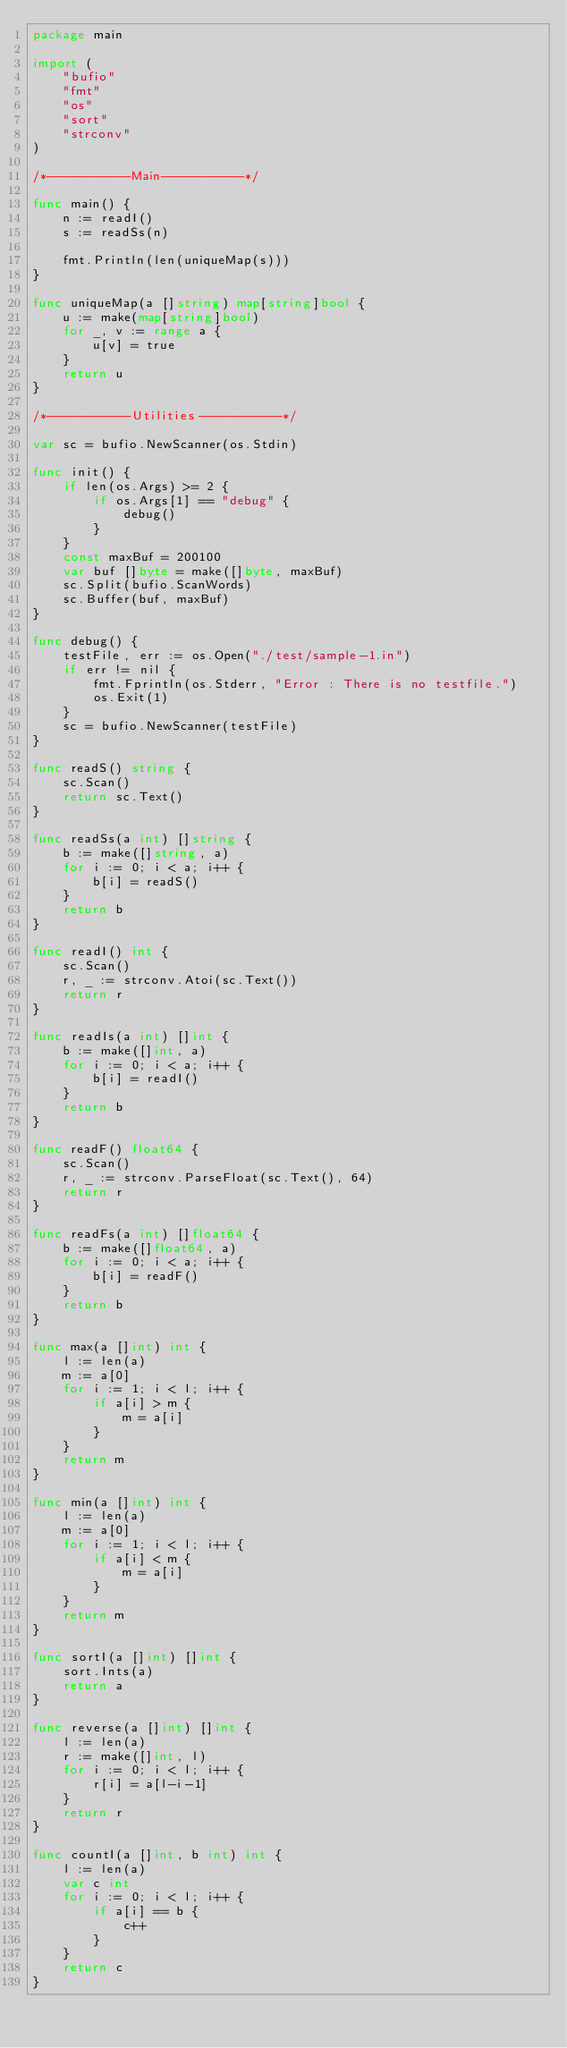Convert code to text. <code><loc_0><loc_0><loc_500><loc_500><_Go_>package main

import (
	"bufio"
	"fmt"
	"os"
	"sort"
	"strconv"
)

/*-----------Main-----------*/

func main() {
	n := readI()
	s := readSs(n)

	fmt.Println(len(uniqueMap(s)))
}

func uniqueMap(a []string) map[string]bool {
	u := make(map[string]bool)
	for _, v := range a {
		u[v] = true
	}
	return u
}

/*-----------Utilities-----------*/

var sc = bufio.NewScanner(os.Stdin)

func init() {
	if len(os.Args) >= 2 {
		if os.Args[1] == "debug" {
			debug()
		}
	}
	const maxBuf = 200100
	var buf []byte = make([]byte, maxBuf)
	sc.Split(bufio.ScanWords)
	sc.Buffer(buf, maxBuf)
}

func debug() {
	testFile, err := os.Open("./test/sample-1.in")
	if err != nil {
		fmt.Fprintln(os.Stderr, "Error : There is no testfile.")
		os.Exit(1)
	}
	sc = bufio.NewScanner(testFile)
}

func readS() string {
	sc.Scan()
	return sc.Text()
}

func readSs(a int) []string {
	b := make([]string, a)
	for i := 0; i < a; i++ {
		b[i] = readS()
	}
	return b
}

func readI() int {
	sc.Scan()
	r, _ := strconv.Atoi(sc.Text())
	return r
}

func readIs(a int) []int {
	b := make([]int, a)
	for i := 0; i < a; i++ {
		b[i] = readI()
	}
	return b
}

func readF() float64 {
	sc.Scan()
	r, _ := strconv.ParseFloat(sc.Text(), 64)
	return r
}

func readFs(a int) []float64 {
	b := make([]float64, a)
	for i := 0; i < a; i++ {
		b[i] = readF()
	}
	return b
}

func max(a []int) int {
	l := len(a)
	m := a[0]
	for i := 1; i < l; i++ {
		if a[i] > m {
			m = a[i]
		}
	}
	return m
}

func min(a []int) int {
	l := len(a)
	m := a[0]
	for i := 1; i < l; i++ {
		if a[i] < m {
			m = a[i]
		}
	}
	return m
}

func sortI(a []int) []int {
	sort.Ints(a)
	return a
}

func reverse(a []int) []int {
	l := len(a)
	r := make([]int, l)
	for i := 0; i < l; i++ {
		r[i] = a[l-i-1]
	}
	return r
}

func countI(a []int, b int) int {
	l := len(a)
	var c int
	for i := 0; i < l; i++ {
		if a[i] == b {
			c++
		}
	}
	return c
}
</code> 